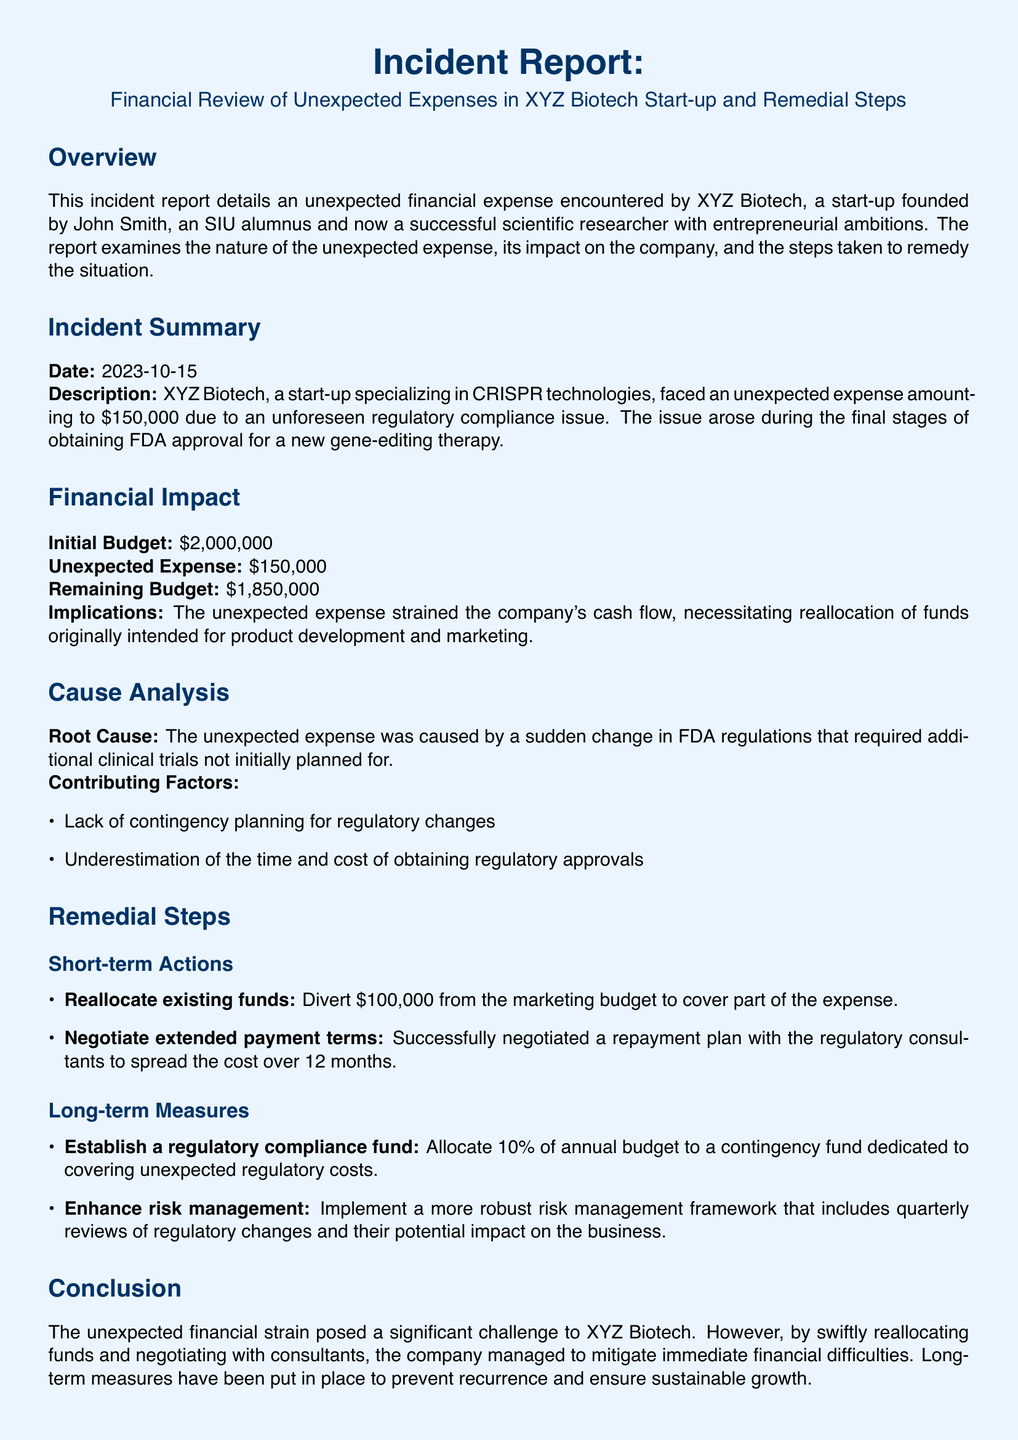What is the date of the incident? The date is specified in the incident summary section.
Answer: 2023-10-15 What was the unexpected expense amount? The unexpected expense amount is outlined in the financial impact section.
Answer: $150,000 Who is the founder of XYZ Biotech? The founder’s name is mentioned in the overview section.
Answer: John Smith What percentage of the annual budget is allocated to the regulatory compliance fund? This detail is found in the long-term measures section.
Answer: 10% What was the initial budget of XYZ Biotech? The initial budget is listed in the financial impact section.
Answer: $2,000,000 What immediate action was taken to cover part of the unexpected expense? This information is derived from the short-term actions section.
Answer: Reallocate existing funds What caused the unexpected expense? The root cause is detailed in the cause analysis section.
Answer: Sudden change in FDA regulations What type of framework will be implemented for better risk management? This is mentioned in the long-term measures section.
Answer: More robust risk management framework What is recommended to maintain ongoing relationships with regulatory experts? This recommendation is found in the recommendations section.
Answer: Engage with regulatory experts 